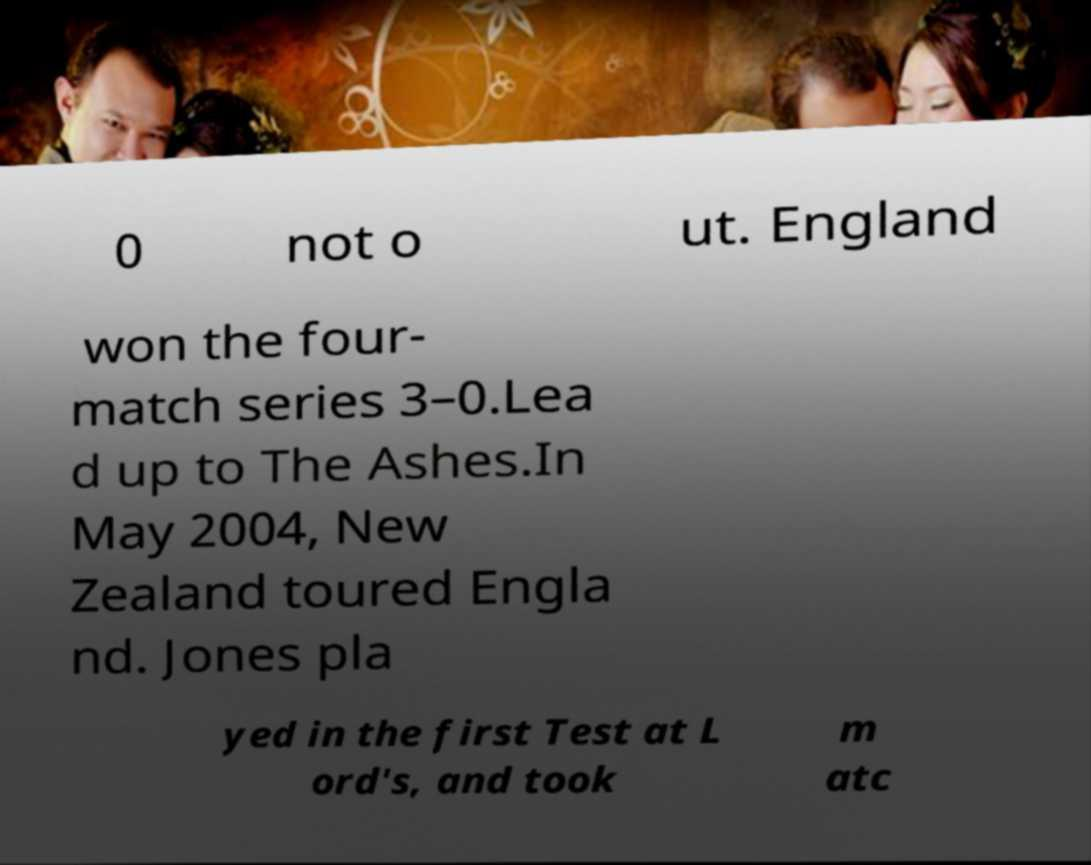Could you assist in decoding the text presented in this image and type it out clearly? 0 not o ut. England won the four- match series 3–0.Lea d up to The Ashes.In May 2004, New Zealand toured Engla nd. Jones pla yed in the first Test at L ord's, and took m atc 